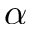<formula> <loc_0><loc_0><loc_500><loc_500>\alpha</formula> 